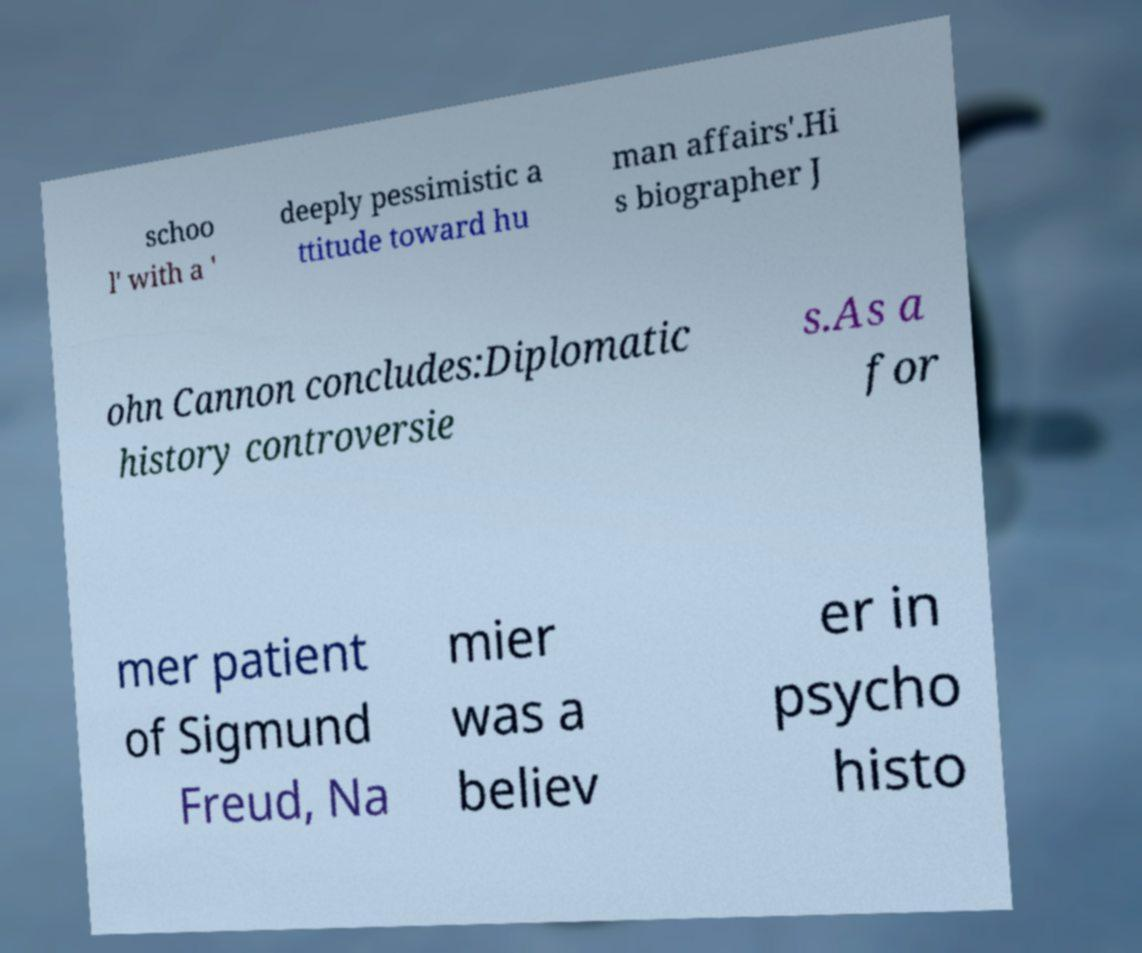For documentation purposes, I need the text within this image transcribed. Could you provide that? schoo l' with a ' deeply pessimistic a ttitude toward hu man affairs'.Hi s biographer J ohn Cannon concludes:Diplomatic history controversie s.As a for mer patient of Sigmund Freud, Na mier was a believ er in psycho histo 